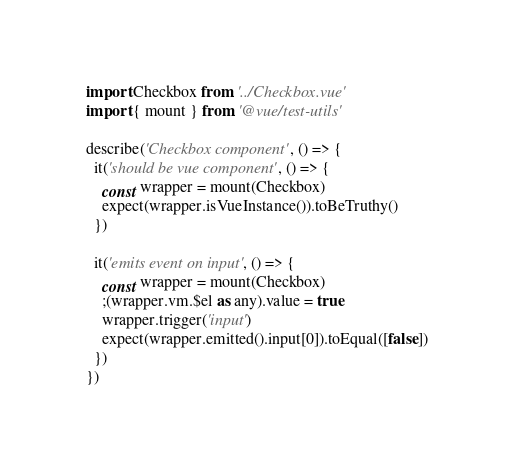<code> <loc_0><loc_0><loc_500><loc_500><_TypeScript_>import Checkbox from '../Checkbox.vue'
import { mount } from '@vue/test-utils'

describe('Checkbox component', () => {
  it('should be vue component', () => {
    const wrapper = mount(Checkbox)
    expect(wrapper.isVueInstance()).toBeTruthy()
  })

  it('emits event on input', () => {
    const wrapper = mount(Checkbox)
    ;(wrapper.vm.$el as any).value = true
    wrapper.trigger('input')
    expect(wrapper.emitted().input[0]).toEqual([false])
  })
})
</code> 